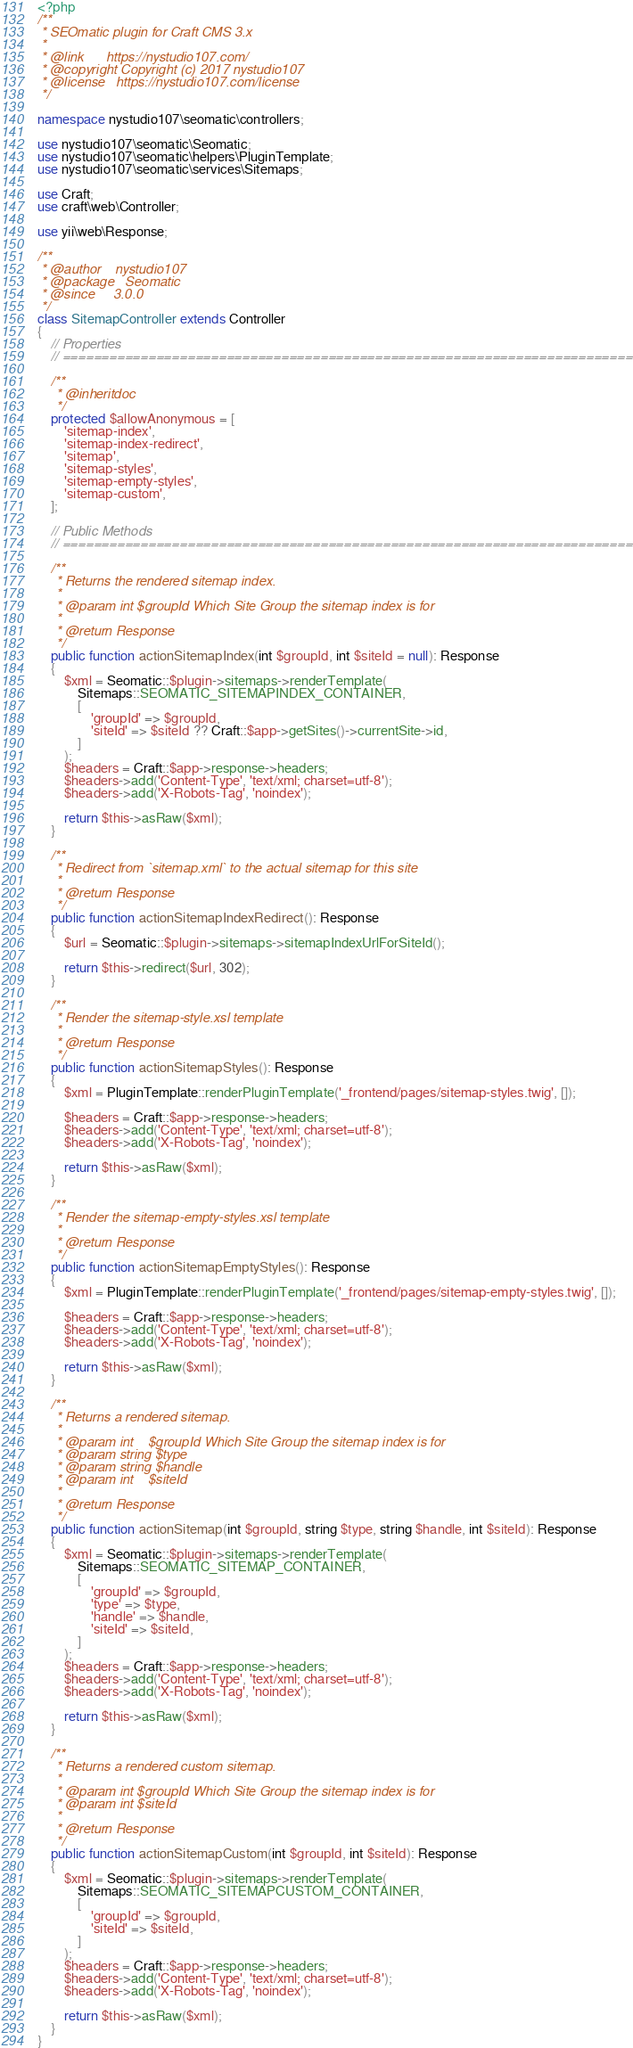<code> <loc_0><loc_0><loc_500><loc_500><_PHP_><?php
/**
 * SEOmatic plugin for Craft CMS 3.x
 *
 * @link      https://nystudio107.com/
 * @copyright Copyright (c) 2017 nystudio107
 * @license   https://nystudio107.com/license
 */

namespace nystudio107\seomatic\controllers;

use nystudio107\seomatic\Seomatic;
use nystudio107\seomatic\helpers\PluginTemplate;
use nystudio107\seomatic\services\Sitemaps;

use Craft;
use craft\web\Controller;

use yii\web\Response;

/**
 * @author    nystudio107
 * @package   Seomatic
 * @since     3.0.0
 */
class SitemapController extends Controller
{
    // Properties
    // =========================================================================

    /**
     * @inheritdoc
     */
    protected $allowAnonymous = [
        'sitemap-index',
        'sitemap-index-redirect',
        'sitemap',
        'sitemap-styles',
        'sitemap-empty-styles',
        'sitemap-custom',
    ];

    // Public Methods
    // =========================================================================

    /**
     * Returns the rendered sitemap index.
     *
     * @param int $groupId Which Site Group the sitemap index is for
     *
     * @return Response
     */
    public function actionSitemapIndex(int $groupId, int $siteId = null): Response
    {
        $xml = Seomatic::$plugin->sitemaps->renderTemplate(
            Sitemaps::SEOMATIC_SITEMAPINDEX_CONTAINER,
            [
                'groupId' => $groupId,
                'siteId' => $siteId ?? Craft::$app->getSites()->currentSite->id,
            ]
        );
        $headers = Craft::$app->response->headers;
        $headers->add('Content-Type', 'text/xml; charset=utf-8');
        $headers->add('X-Robots-Tag', 'noindex');

        return $this->asRaw($xml);
    }

    /**
     * Redirect from `sitemap.xml` to the actual sitemap for this site
     *
     * @return Response
     */
    public function actionSitemapIndexRedirect(): Response
    {
        $url = Seomatic::$plugin->sitemaps->sitemapIndexUrlForSiteId();

        return $this->redirect($url, 302);
    }

    /**
     * Render the sitemap-style.xsl template
     *
     * @return Response
     */
    public function actionSitemapStyles(): Response
    {
        $xml = PluginTemplate::renderPluginTemplate('_frontend/pages/sitemap-styles.twig', []);

        $headers = Craft::$app->response->headers;
        $headers->add('Content-Type', 'text/xml; charset=utf-8');
        $headers->add('X-Robots-Tag', 'noindex');

        return $this->asRaw($xml);
    }

    /**
     * Render the sitemap-empty-styles.xsl template
     *
     * @return Response
     */
    public function actionSitemapEmptyStyles(): Response
    {
        $xml = PluginTemplate::renderPluginTemplate('_frontend/pages/sitemap-empty-styles.twig', []);

        $headers = Craft::$app->response->headers;
        $headers->add('Content-Type', 'text/xml; charset=utf-8');
        $headers->add('X-Robots-Tag', 'noindex');

        return $this->asRaw($xml);
    }

    /**
     * Returns a rendered sitemap.
     *
     * @param int    $groupId Which Site Group the sitemap index is for
     * @param string $type
     * @param string $handle
     * @param int    $siteId
     *
     * @return Response
     */
    public function actionSitemap(int $groupId, string $type, string $handle, int $siteId): Response
    {
        $xml = Seomatic::$plugin->sitemaps->renderTemplate(
            Sitemaps::SEOMATIC_SITEMAP_CONTAINER,
            [
                'groupId' => $groupId,
                'type' => $type,
                'handle' => $handle,
                'siteId' => $siteId,
            ]
        );
        $headers = Craft::$app->response->headers;
        $headers->add('Content-Type', 'text/xml; charset=utf-8');
        $headers->add('X-Robots-Tag', 'noindex');

        return $this->asRaw($xml);
    }

    /**
     * Returns a rendered custom sitemap.
     *
     * @param int $groupId Which Site Group the sitemap index is for
     * @param int $siteId
     *
     * @return Response
     */
    public function actionSitemapCustom(int $groupId, int $siteId): Response
    {
        $xml = Seomatic::$plugin->sitemaps->renderTemplate(
            Sitemaps::SEOMATIC_SITEMAPCUSTOM_CONTAINER,
            [
                'groupId' => $groupId,
                'siteId' => $siteId,
            ]
        );
        $headers = Craft::$app->response->headers;
        $headers->add('Content-Type', 'text/xml; charset=utf-8');
        $headers->add('X-Robots-Tag', 'noindex');

        return $this->asRaw($xml);
    }
}
</code> 